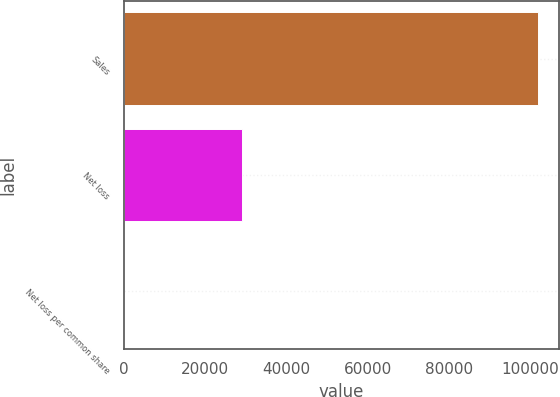<chart> <loc_0><loc_0><loc_500><loc_500><bar_chart><fcel>Sales<fcel>Net loss<fcel>Net loss per common share<nl><fcel>102085<fcel>29133<fcel>0.92<nl></chart> 